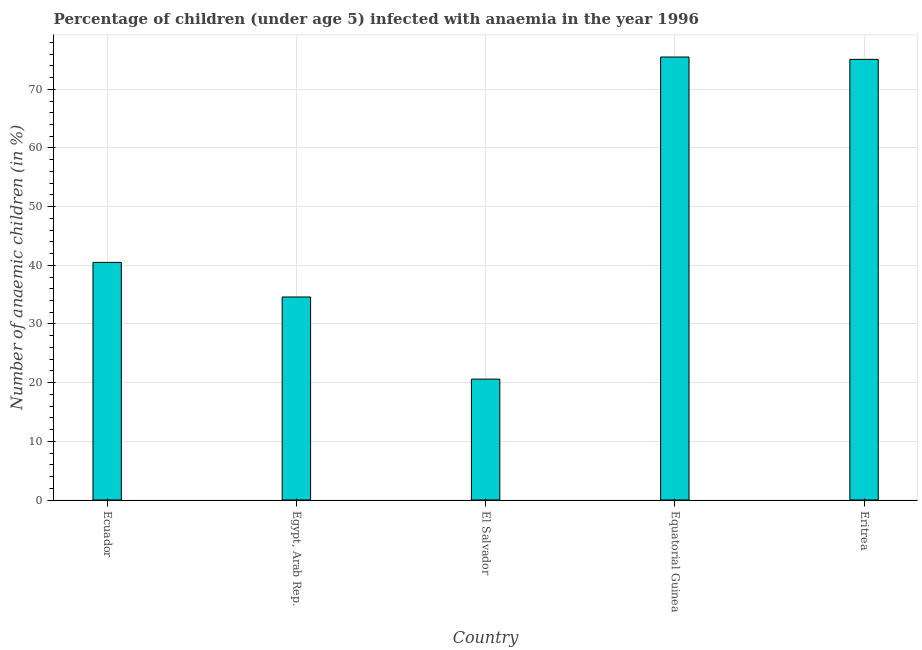Does the graph contain any zero values?
Keep it short and to the point. No. What is the title of the graph?
Offer a terse response. Percentage of children (under age 5) infected with anaemia in the year 1996. What is the label or title of the Y-axis?
Ensure brevity in your answer.  Number of anaemic children (in %). What is the number of anaemic children in El Salvador?
Your answer should be very brief. 20.6. Across all countries, what is the maximum number of anaemic children?
Provide a succinct answer. 75.5. Across all countries, what is the minimum number of anaemic children?
Keep it short and to the point. 20.6. In which country was the number of anaemic children maximum?
Ensure brevity in your answer.  Equatorial Guinea. In which country was the number of anaemic children minimum?
Your response must be concise. El Salvador. What is the sum of the number of anaemic children?
Provide a succinct answer. 246.3. What is the difference between the number of anaemic children in El Salvador and Eritrea?
Your response must be concise. -54.5. What is the average number of anaemic children per country?
Make the answer very short. 49.26. What is the median number of anaemic children?
Your answer should be very brief. 40.5. What is the ratio of the number of anaemic children in Egypt, Arab Rep. to that in El Salvador?
Provide a short and direct response. 1.68. What is the difference between the highest and the second highest number of anaemic children?
Keep it short and to the point. 0.4. Is the sum of the number of anaemic children in Ecuador and Equatorial Guinea greater than the maximum number of anaemic children across all countries?
Give a very brief answer. Yes. What is the difference between the highest and the lowest number of anaemic children?
Offer a terse response. 54.9. How many countries are there in the graph?
Ensure brevity in your answer.  5. Are the values on the major ticks of Y-axis written in scientific E-notation?
Ensure brevity in your answer.  No. What is the Number of anaemic children (in %) in Ecuador?
Provide a short and direct response. 40.5. What is the Number of anaemic children (in %) in Egypt, Arab Rep.?
Provide a short and direct response. 34.6. What is the Number of anaemic children (in %) of El Salvador?
Your response must be concise. 20.6. What is the Number of anaemic children (in %) of Equatorial Guinea?
Offer a very short reply. 75.5. What is the Number of anaemic children (in %) of Eritrea?
Your answer should be compact. 75.1. What is the difference between the Number of anaemic children (in %) in Ecuador and Egypt, Arab Rep.?
Your response must be concise. 5.9. What is the difference between the Number of anaemic children (in %) in Ecuador and El Salvador?
Offer a very short reply. 19.9. What is the difference between the Number of anaemic children (in %) in Ecuador and Equatorial Guinea?
Provide a succinct answer. -35. What is the difference between the Number of anaemic children (in %) in Ecuador and Eritrea?
Your answer should be compact. -34.6. What is the difference between the Number of anaemic children (in %) in Egypt, Arab Rep. and Equatorial Guinea?
Provide a short and direct response. -40.9. What is the difference between the Number of anaemic children (in %) in Egypt, Arab Rep. and Eritrea?
Your answer should be compact. -40.5. What is the difference between the Number of anaemic children (in %) in El Salvador and Equatorial Guinea?
Provide a succinct answer. -54.9. What is the difference between the Number of anaemic children (in %) in El Salvador and Eritrea?
Provide a short and direct response. -54.5. What is the ratio of the Number of anaemic children (in %) in Ecuador to that in Egypt, Arab Rep.?
Offer a very short reply. 1.17. What is the ratio of the Number of anaemic children (in %) in Ecuador to that in El Salvador?
Your answer should be very brief. 1.97. What is the ratio of the Number of anaemic children (in %) in Ecuador to that in Equatorial Guinea?
Your response must be concise. 0.54. What is the ratio of the Number of anaemic children (in %) in Ecuador to that in Eritrea?
Give a very brief answer. 0.54. What is the ratio of the Number of anaemic children (in %) in Egypt, Arab Rep. to that in El Salvador?
Your answer should be very brief. 1.68. What is the ratio of the Number of anaemic children (in %) in Egypt, Arab Rep. to that in Equatorial Guinea?
Your answer should be very brief. 0.46. What is the ratio of the Number of anaemic children (in %) in Egypt, Arab Rep. to that in Eritrea?
Your answer should be very brief. 0.46. What is the ratio of the Number of anaemic children (in %) in El Salvador to that in Equatorial Guinea?
Ensure brevity in your answer.  0.27. What is the ratio of the Number of anaemic children (in %) in El Salvador to that in Eritrea?
Offer a very short reply. 0.27. What is the ratio of the Number of anaemic children (in %) in Equatorial Guinea to that in Eritrea?
Offer a terse response. 1. 